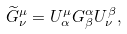<formula> <loc_0><loc_0><loc_500><loc_500>\widetilde { G } _ { \nu } ^ { \mu } = U _ { \alpha } ^ { \mu } G _ { \beta } ^ { \alpha } U _ { \nu } ^ { \beta } ,</formula> 